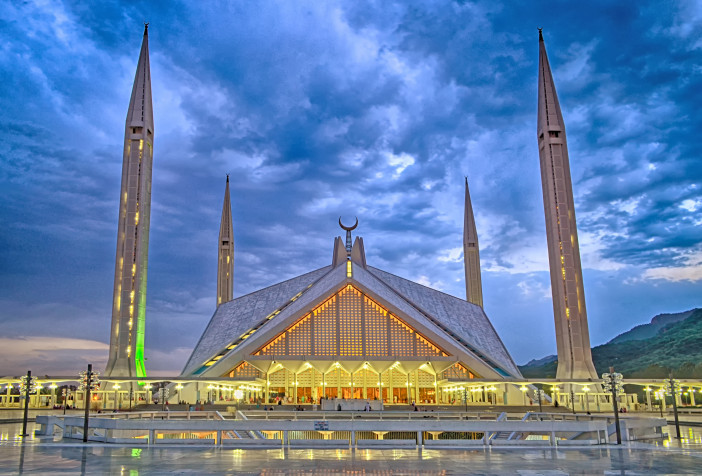What role does the Faisal Mosque play in the community of Islamabad? The Faisal Mosque serves multiple roles in the Islamabad community. Beyond being a primary place for daily prayers and major religious ceremonies, it stands as a cultural hub where people gather for educational events, lectures, and festivities. Its expansive grounds and welcoming design also make it a point of interest for tourists and locals alike, fostering a sense of unity and pride within the community. 